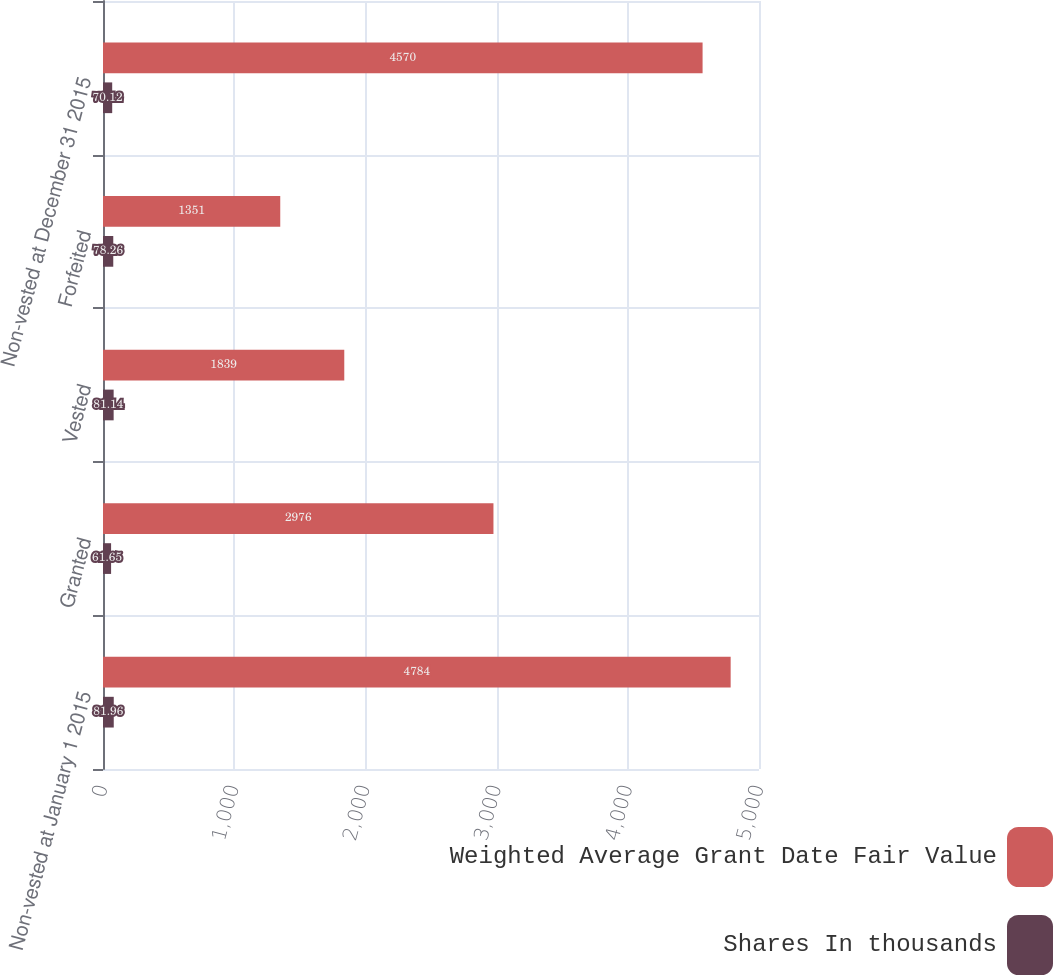<chart> <loc_0><loc_0><loc_500><loc_500><stacked_bar_chart><ecel><fcel>Non-vested at January 1 2015<fcel>Granted<fcel>Vested<fcel>Forfeited<fcel>Non-vested at December 31 2015<nl><fcel>Weighted Average Grant Date Fair Value<fcel>4784<fcel>2976<fcel>1839<fcel>1351<fcel>4570<nl><fcel>Shares In thousands<fcel>81.96<fcel>61.65<fcel>81.14<fcel>78.26<fcel>70.12<nl></chart> 